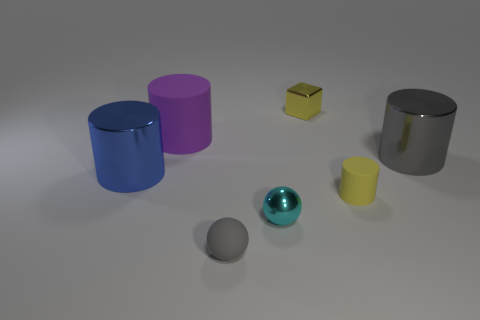Add 1 gray rubber objects. How many objects exist? 8 Subtract all balls. How many objects are left? 5 Add 3 blue metal cylinders. How many blue metal cylinders exist? 4 Subtract 0 purple balls. How many objects are left? 7 Subtract all cyan balls. Subtract all cylinders. How many objects are left? 2 Add 4 shiny cylinders. How many shiny cylinders are left? 6 